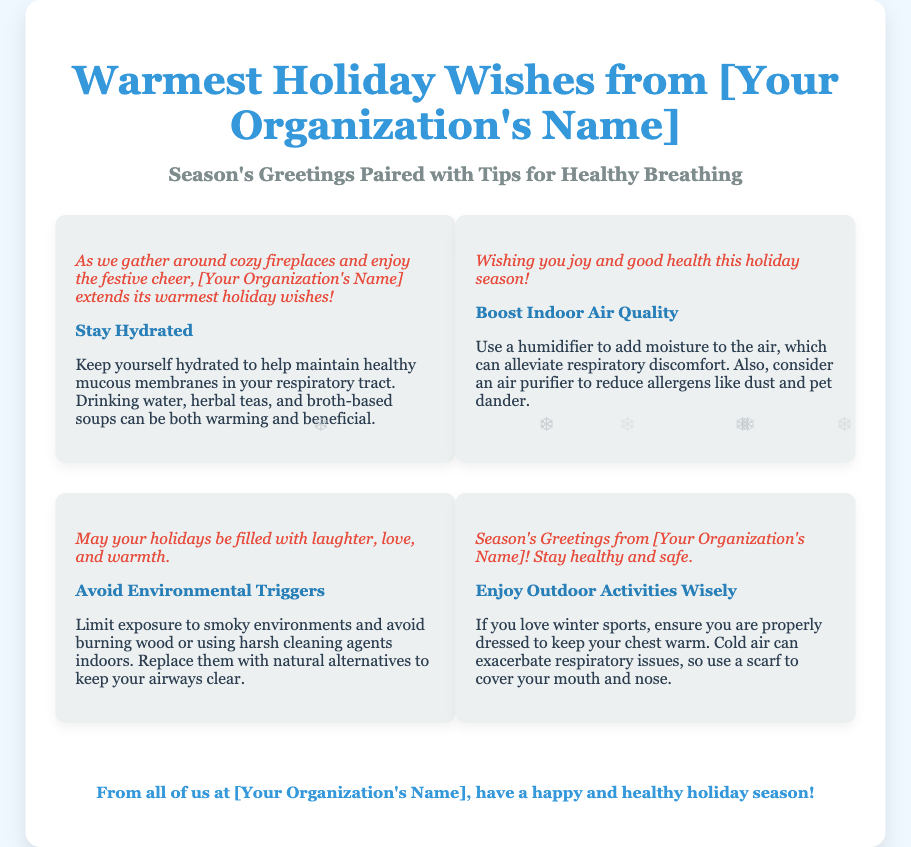what is the title of the document? The title is specified in the head section as "Holiday Wishes for Respiratory Health".
Answer: Holiday Wishes for Respiratory Health how many festive greetings are included in the card? There are four sections, each containing a festive greeting.
Answer: Four what tip is provided to enhance indoor air quality? The card mentions using a humidifier and considering an air purifier.
Answer: Use a humidifier who extends the holiday wishes? The holiday wishes are extended by the organization mentioned in the card.
Answer: [Your Organization's Name] what type of activities does the card suggest enjoying wisely? The card suggests enjoying outdoor activities, specifically winter sports.
Answer: Outdoor activities which design motif is mentioned in the greeting card? The greeting card includes the motif of cozy fireplaces.
Answer: Cozy fireplaces what should you do to stay hydrated according to the card? The card recommends drinking water, herbal teas, and broth-based soups.
Answer: Drink water what is the footer message in the card? The footer expresses a wish for a happy and healthy holiday season from the organization.
Answer: have a happy and healthy holiday season 